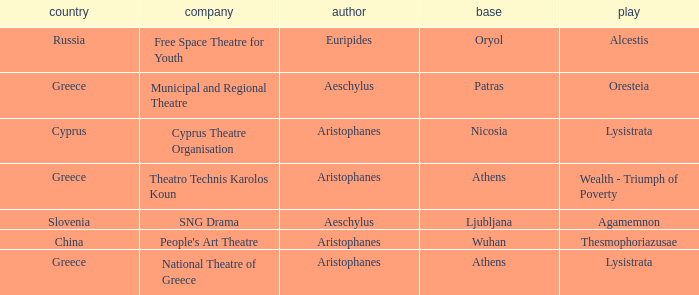What is the country when the base is ljubljana? Slovenia. 